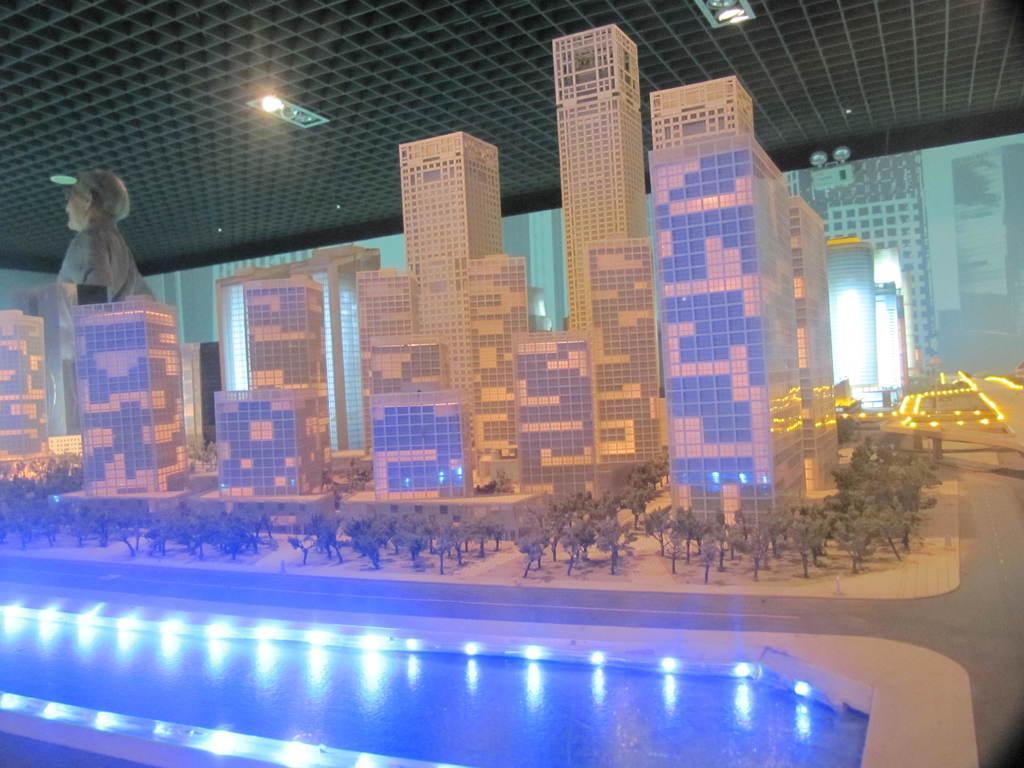Describe this image in one or two sentences. In this picture we can see water, here we can see buildings, trees and a statue of a person, lights and in the background we can see a roof. 